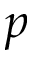<formula> <loc_0><loc_0><loc_500><loc_500>p</formula> 